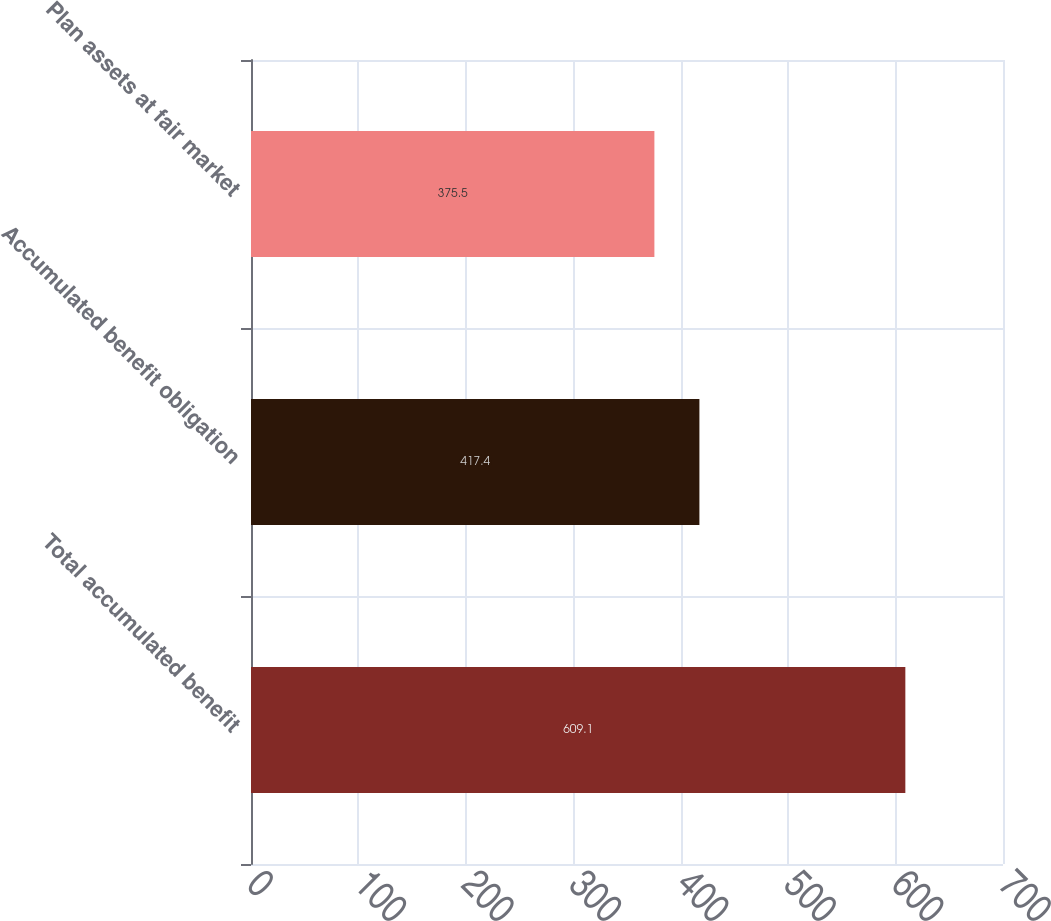<chart> <loc_0><loc_0><loc_500><loc_500><bar_chart><fcel>Total accumulated benefit<fcel>Accumulated benefit obligation<fcel>Plan assets at fair market<nl><fcel>609.1<fcel>417.4<fcel>375.5<nl></chart> 